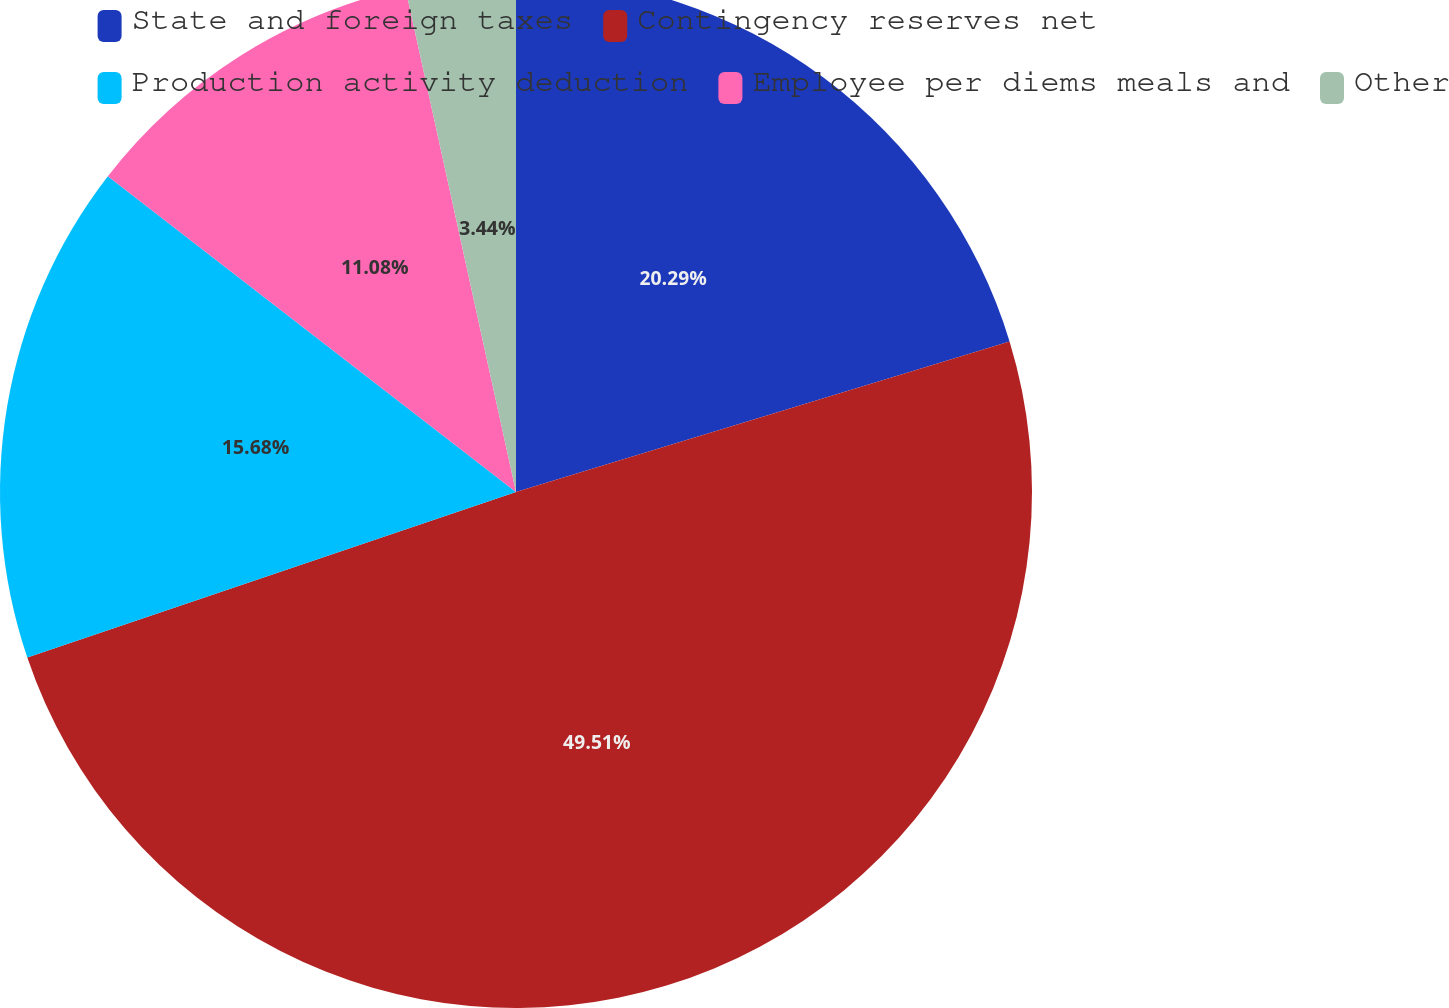Convert chart to OTSL. <chart><loc_0><loc_0><loc_500><loc_500><pie_chart><fcel>State and foreign taxes<fcel>Contingency reserves net<fcel>Production activity deduction<fcel>Employee per diems meals and<fcel>Other<nl><fcel>20.29%<fcel>49.51%<fcel>15.68%<fcel>11.08%<fcel>3.44%<nl></chart> 